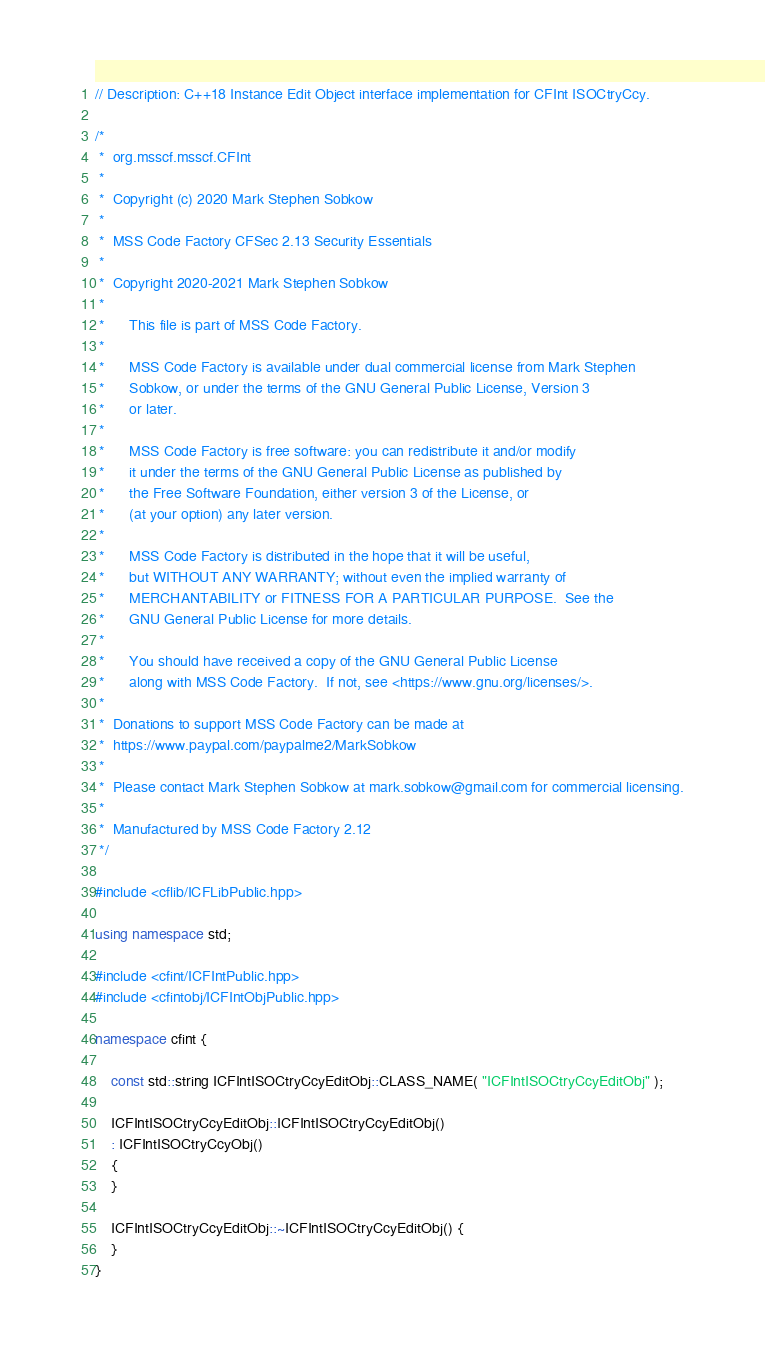Convert code to text. <code><loc_0><loc_0><loc_500><loc_500><_C++_>// Description: C++18 Instance Edit Object interface implementation for CFInt ISOCtryCcy.

/*
 *	org.msscf.msscf.CFInt
 *
 *	Copyright (c) 2020 Mark Stephen Sobkow
 *	
 *	MSS Code Factory CFSec 2.13 Security Essentials
 *	
 *	Copyright 2020-2021 Mark Stephen Sobkow
 *	
 *		This file is part of MSS Code Factory.
 *	
 *		MSS Code Factory is available under dual commercial license from Mark Stephen
 *		Sobkow, or under the terms of the GNU General Public License, Version 3
 *		or later.
 *	
 *	    MSS Code Factory is free software: you can redistribute it and/or modify
 *	    it under the terms of the GNU General Public License as published by
 *	    the Free Software Foundation, either version 3 of the License, or
 *	    (at your option) any later version.
 *	
 *	    MSS Code Factory is distributed in the hope that it will be useful,
 *	    but WITHOUT ANY WARRANTY; without even the implied warranty of
 *	    MERCHANTABILITY or FITNESS FOR A PARTICULAR PURPOSE.  See the
 *	    GNU General Public License for more details.
 *	
 *	    You should have received a copy of the GNU General Public License
 *	    along with MSS Code Factory.  If not, see <https://www.gnu.org/licenses/>.
 *	
 *	Donations to support MSS Code Factory can be made at
 *	https://www.paypal.com/paypalme2/MarkSobkow
 *	
 *	Please contact Mark Stephen Sobkow at mark.sobkow@gmail.com for commercial licensing.
 *
 *	Manufactured by MSS Code Factory 2.12
 */

#include <cflib/ICFLibPublic.hpp>

using namespace std;

#include <cfint/ICFIntPublic.hpp>
#include <cfintobj/ICFIntObjPublic.hpp>

namespace cfint {

	const std::string ICFIntISOCtryCcyEditObj::CLASS_NAME( "ICFIntISOCtryCcyEditObj" );

	ICFIntISOCtryCcyEditObj::ICFIntISOCtryCcyEditObj()
	: ICFIntISOCtryCcyObj()
	{
	}

	ICFIntISOCtryCcyEditObj::~ICFIntISOCtryCcyEditObj() {
	}
}
</code> 